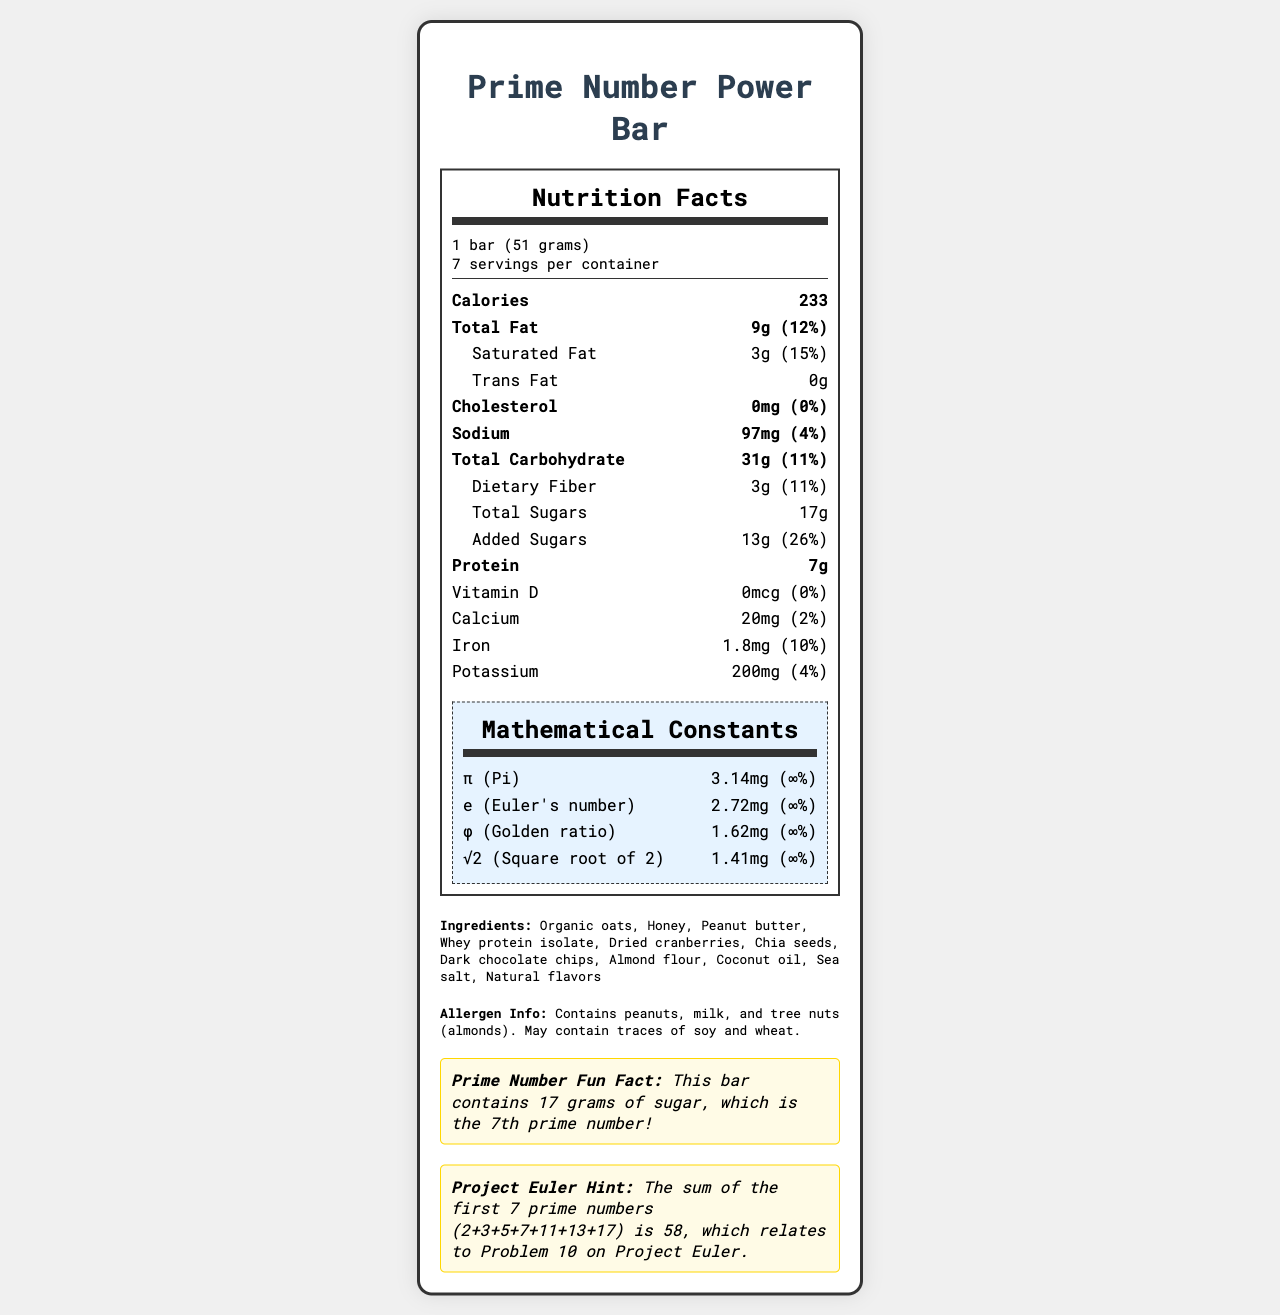what is the serving size? The serving size is listed at the top of the nutrition facts under the serving info section.
Answer: 1 bar (51 grams) how many calories are there per bar? The number of calories per bar is highlighted in bold in the nutrient rows just below the serving info.
Answer: 233 how much saturated fat is in one bar? The saturated fat content is listed under the Total Fat section and is specified as 3g.
Answer: 3g what is the amount of protein in one bar? The protein content is listed in the nutrient rows and specified as 7g.
Answer: 7g what is the daily value percentage of added sugars? The daily value percentage for added sugars is shown as 26% under the Total Sugars section.
Answer: 26% which ingredient is not in the bar? A. Almond flour B. Sea salt C. Soy protein The ingredient list includes almond flour and sea salt but does not mention soy protein.
Answer: C what is the sodium content per serving? A. 97mg B. 97g C. 970mg D. 9.7mg The sodium content per serving is listed as 97mg in the nutrient rows.
Answer: A does this bar contain any vitamin D? The vitamin D content is listed as 0mcg with a 0% daily value.
Answer: No summarize the main idea of this document. The document is a detailed nutrition label for the Prime Number Power Bar, highlighting its caloric, macronutrient content, ingredients, allergen info, fun facts about prime numbers, and mathematical constants.
Answer: The document provides the nutrition facts for the "Prime Number Power Bar," including serving size, calories, macronutrient details, and mathematical constants as micronutrients. It also lists ingredients, allergen information, a prime number fun fact, and a Project Euler hint. what is the fun fact related to prime numbers? The fun fact is located in a highlighted section at the bottom of the document and states that 17 grams of sugar is the 7th prime number.
Answer: The bar contains 17 grams of sugar, which is the 7th prime number! how much iron is in one bar? The amount of iron is listed in the nutrient rows specifying 1.8mg.
Answer: 1.8mg what are the mathematical constants listed on the label? These constants are listed in the mathematical constants section towards the end of the nutrition label.
Answer: π (Pi), e (Euler's number), φ (Golden ratio), and √2 (Square root of 2) what is the daily value percentage of calcium? The document lists the calcium content as 20mg, which corresponds to a 2% daily value.
Answer: 2% what is the allergen information for this bar? The allergen info is listed in a separate section below the ingredients.
Answer: Contains peanuts, milk, and tree nuts (almonds). May contain traces of soy and wheat. which mathematical constant has the highest amount in milligrams? A. π (Pi) B. e (Euler's number) C. φ (Golden ratio) D. √2 (Square root of 2) π (Pi) has the highest amount listed as 3.14mg.
Answer: A is there any cholesterol in this bar? The cholesterol content is listed as 0mg with a 0% daily value.
Answer: No which macronutrient has the highest daily value percentage in this bar? Among all listed macronutrients, added sugars have the highest daily value percentage of 26%.
Answer: Added Sugars (26%) what is the Project Euler hint provided in the document? The Project Euler hint is stated in the fun facts section and relates to the sum of the first 7 prime numbers.
Answer: The sum of the first 7 prime numbers (2+3+5+7+11+13+17) is 58, which relates to Problem 10 on Project Euler. if consumed a whole container, how many bars would that be? The serving info states that there are 7 servings per container.
Answer: 7 bars what are the sugars and added sugars content per serving? The total sugars are listed as 17g, with 13g specified as added sugars.
Answer: 17g total sugars, 13g added sugars how many ingredients are listed on the label? The document lists 11 ingredients in the ingredients section.
Answer: 11 ingredients what is the daily value percentage of the golden ratio as a nutrient? The daily value percentage for the golden ratio is shown as ∞% in the mathematical constants section.
Answer: ∞% how much dietary fiber is in one bar? The dietary fiber content is listed under Total Carbohydrate as 3g.
Answer: 3g how many servings are in one container? The servings per container are listed at the top of the nutrition facts under the serving info section.
Answer: 7 what is the daily value percentage of potassium? The daily value percentage for potassium is listed as 4%.
Answer: 4% does this bar contain any almond flour? Almond flour is listed in the ingredients section of the label.
Answer: Yes which of the following is not a nutrient mentioned in the bar? A. Vitamin A B. Vitamin D C. Calcium The document mentions Vitamin D and Calcium but mentions nothing about Vitamin A.
Answer: A how much calcium is found in one serving of the bar? The document lists calcium content as 20mg in a nutrient row.
Answer: 20mg 